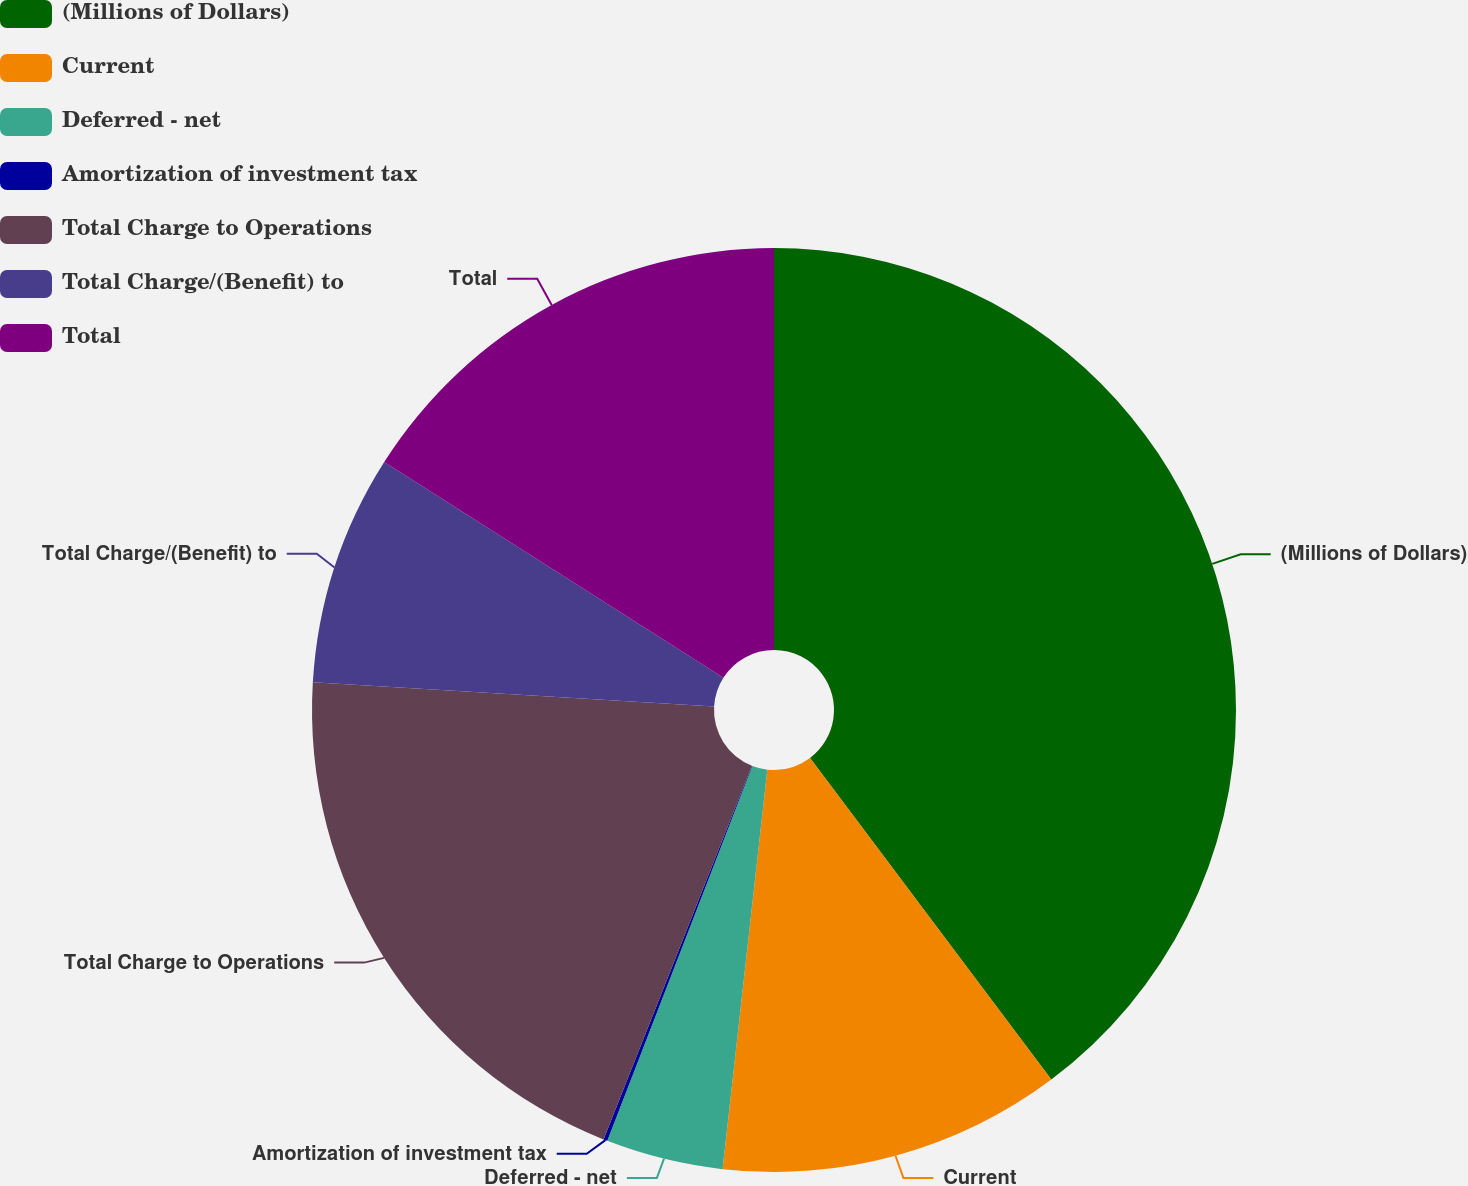<chart> <loc_0><loc_0><loc_500><loc_500><pie_chart><fcel>(Millions of Dollars)<fcel>Current<fcel>Deferred - net<fcel>Amortization of investment tax<fcel>Total Charge to Operations<fcel>Total Charge/(Benefit) to<fcel>Total<nl><fcel>39.75%<fcel>12.02%<fcel>4.1%<fcel>0.14%<fcel>19.94%<fcel>8.06%<fcel>15.98%<nl></chart> 